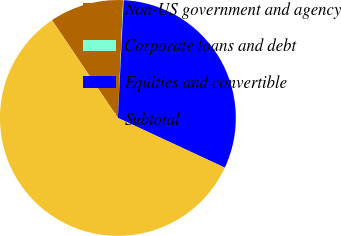Convert chart. <chart><loc_0><loc_0><loc_500><loc_500><pie_chart><fcel>Non-US government and agency<fcel>Corporate loans and debt<fcel>Equities and convertible<fcel>Subtotal<nl><fcel>10.15%<fcel>0.08%<fcel>31.13%<fcel>58.63%<nl></chart> 